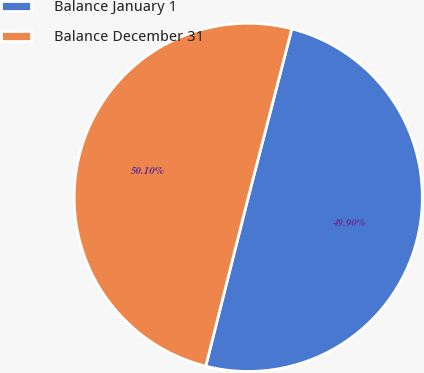Convert chart. <chart><loc_0><loc_0><loc_500><loc_500><pie_chart><fcel>Balance January 1<fcel>Balance December 31<nl><fcel>49.9%<fcel>50.1%<nl></chart> 